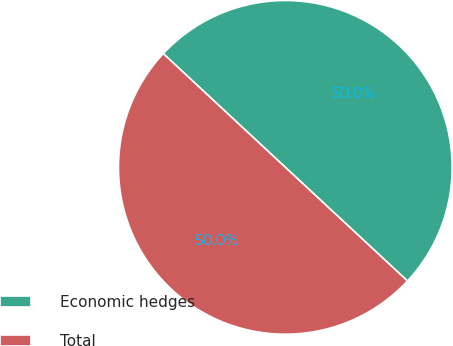Convert chart. <chart><loc_0><loc_0><loc_500><loc_500><pie_chart><fcel>Economic hedges<fcel>Total<nl><fcel>49.99%<fcel>50.01%<nl></chart> 